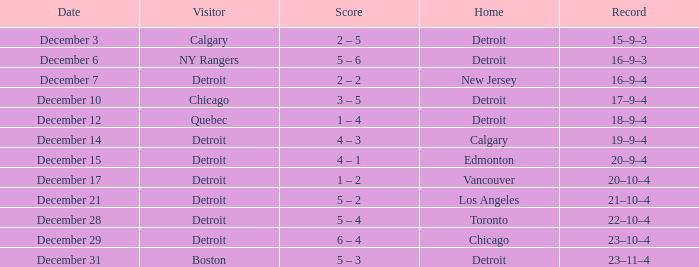When is the home game in detroit taking place with chicago as the away team? December 10. 